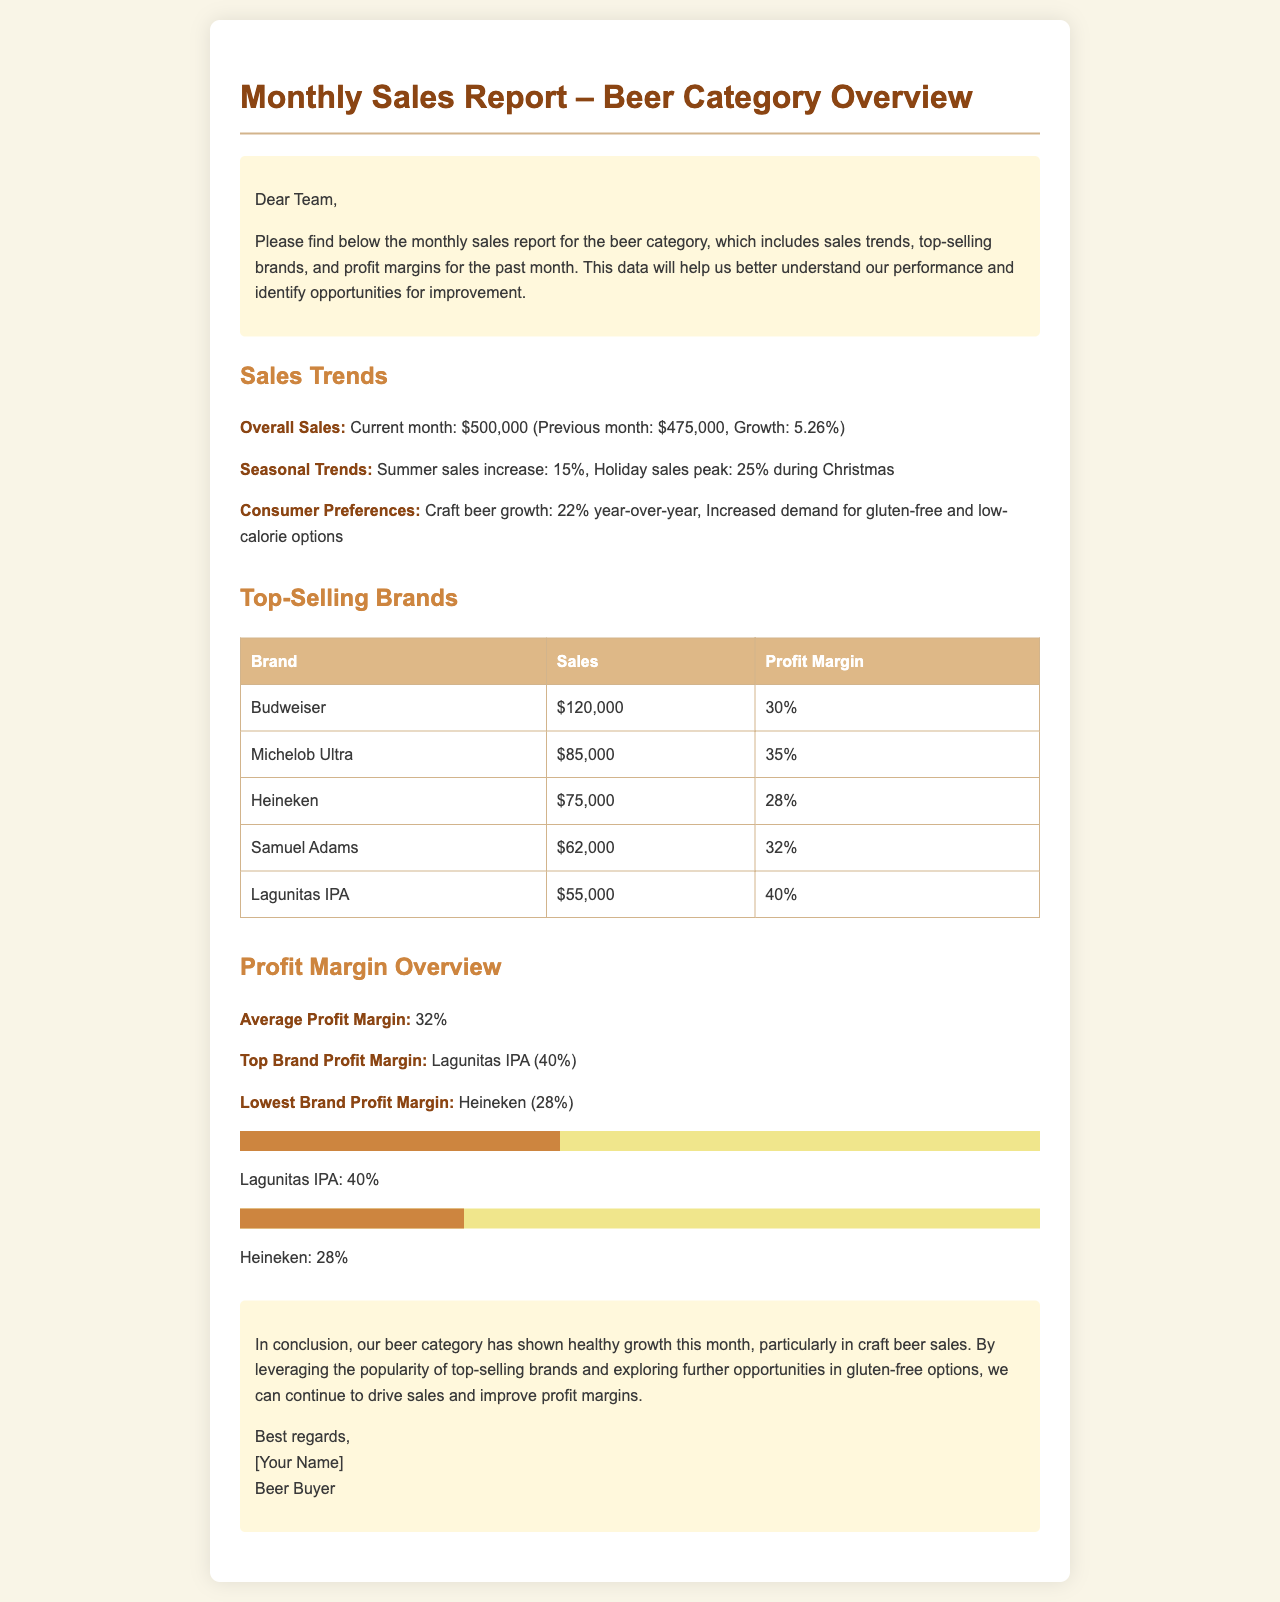What is the overall sales for the current month? The overall sales for the current month is clearly stated in the document as $500,000.
Answer: $500,000 What was the sales growth compared to the previous month? The document mentions a growth rate of 5.26% from the previous month.
Answer: 5.26% Which brand had the highest sales? According to the table, Budweiser had the highest sales of $120,000.
Answer: Budweiser What is the average profit margin for the beer category? The document explicitly states that the average profit margin is 32%.
Answer: 32% Which brand has the lowest profit margin? The document identifies Heineken as the brand with the lowest profit margin of 28%.
Answer: Heineken What was the increase in sales for craft beer year-over-year? The document specifies that craft beer growth is 22% year-over-year.
Answer: 22% Which brand has the highest profit margin? The document highlights Lagunitas IPA as having the highest profit margin of 40%.
Answer: Lagunitas IPA What seasonal sales peak is mentioned for Christmas? The document mentions a holiday sales peak of 25% during Christmas.
Answer: 25% What does the conclusion suggest for future opportunities? The conclusion suggests exploring further opportunities in gluten-free options to drive sales.
Answer: Gluten-free options 